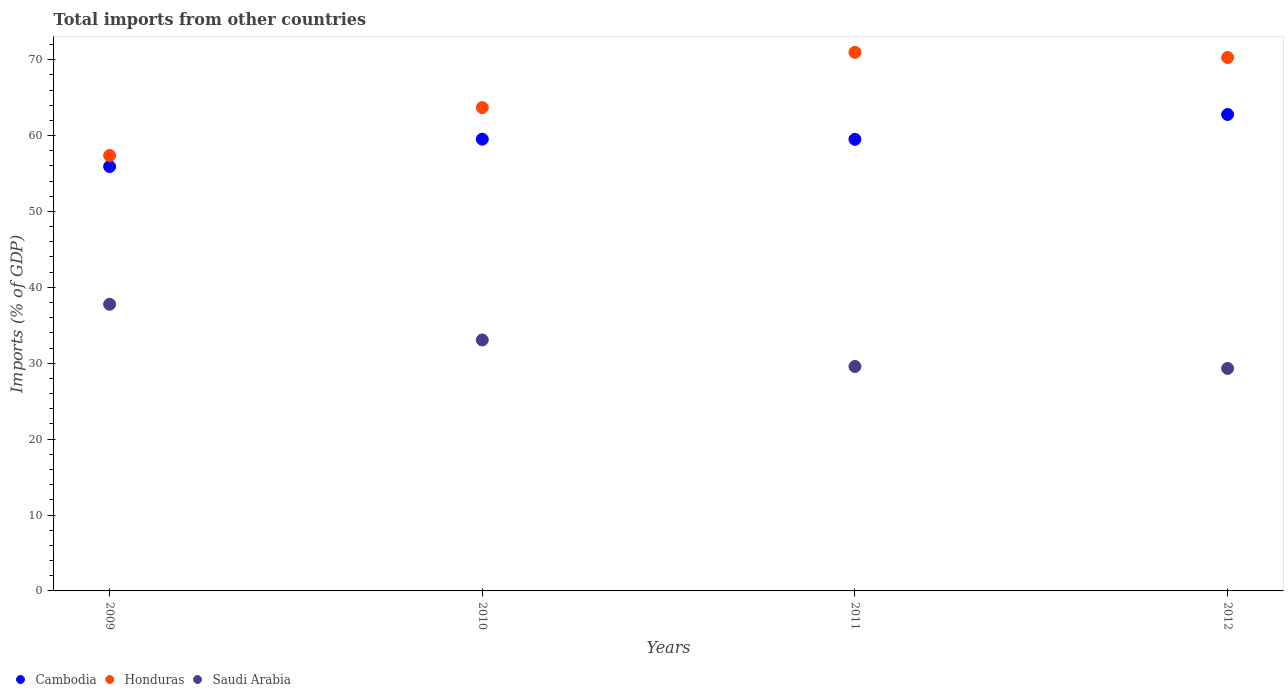How many different coloured dotlines are there?
Provide a succinct answer. 3. What is the total imports in Saudi Arabia in 2010?
Make the answer very short. 33.07. Across all years, what is the maximum total imports in Cambodia?
Your answer should be compact. 62.78. Across all years, what is the minimum total imports in Honduras?
Provide a succinct answer. 57.37. In which year was the total imports in Cambodia maximum?
Make the answer very short. 2012. What is the total total imports in Saudi Arabia in the graph?
Provide a short and direct response. 129.73. What is the difference between the total imports in Cambodia in 2010 and that in 2012?
Your answer should be very brief. -3.26. What is the difference between the total imports in Cambodia in 2011 and the total imports in Saudi Arabia in 2010?
Provide a short and direct response. 26.43. What is the average total imports in Cambodia per year?
Ensure brevity in your answer.  59.43. In the year 2012, what is the difference between the total imports in Cambodia and total imports in Saudi Arabia?
Your answer should be very brief. 33.46. What is the ratio of the total imports in Honduras in 2009 to that in 2012?
Ensure brevity in your answer.  0.82. What is the difference between the highest and the second highest total imports in Cambodia?
Give a very brief answer. 3.26. What is the difference between the highest and the lowest total imports in Honduras?
Ensure brevity in your answer.  13.58. Does the total imports in Honduras monotonically increase over the years?
Your response must be concise. No. Is the total imports in Honduras strictly greater than the total imports in Cambodia over the years?
Ensure brevity in your answer.  Yes. How many years are there in the graph?
Provide a short and direct response. 4. What is the difference between two consecutive major ticks on the Y-axis?
Your answer should be very brief. 10. Are the values on the major ticks of Y-axis written in scientific E-notation?
Your response must be concise. No. Where does the legend appear in the graph?
Make the answer very short. Bottom left. How many legend labels are there?
Provide a short and direct response. 3. What is the title of the graph?
Provide a short and direct response. Total imports from other countries. Does "Sri Lanka" appear as one of the legend labels in the graph?
Provide a short and direct response. No. What is the label or title of the X-axis?
Ensure brevity in your answer.  Years. What is the label or title of the Y-axis?
Your response must be concise. Imports (% of GDP). What is the Imports (% of GDP) of Cambodia in 2009?
Your answer should be very brief. 55.92. What is the Imports (% of GDP) of Honduras in 2009?
Make the answer very short. 57.37. What is the Imports (% of GDP) in Saudi Arabia in 2009?
Make the answer very short. 37.77. What is the Imports (% of GDP) in Cambodia in 2010?
Offer a terse response. 59.52. What is the Imports (% of GDP) of Honduras in 2010?
Offer a very short reply. 63.68. What is the Imports (% of GDP) of Saudi Arabia in 2010?
Provide a succinct answer. 33.07. What is the Imports (% of GDP) of Cambodia in 2011?
Make the answer very short. 59.5. What is the Imports (% of GDP) in Honduras in 2011?
Offer a very short reply. 70.96. What is the Imports (% of GDP) in Saudi Arabia in 2011?
Provide a succinct answer. 29.57. What is the Imports (% of GDP) of Cambodia in 2012?
Keep it short and to the point. 62.78. What is the Imports (% of GDP) in Honduras in 2012?
Offer a very short reply. 70.29. What is the Imports (% of GDP) in Saudi Arabia in 2012?
Your answer should be very brief. 29.32. Across all years, what is the maximum Imports (% of GDP) in Cambodia?
Offer a terse response. 62.78. Across all years, what is the maximum Imports (% of GDP) in Honduras?
Your answer should be very brief. 70.96. Across all years, what is the maximum Imports (% of GDP) of Saudi Arabia?
Offer a terse response. 37.77. Across all years, what is the minimum Imports (% of GDP) of Cambodia?
Your answer should be very brief. 55.92. Across all years, what is the minimum Imports (% of GDP) in Honduras?
Offer a very short reply. 57.37. Across all years, what is the minimum Imports (% of GDP) in Saudi Arabia?
Your answer should be compact. 29.32. What is the total Imports (% of GDP) of Cambodia in the graph?
Keep it short and to the point. 237.72. What is the total Imports (% of GDP) of Honduras in the graph?
Offer a very short reply. 262.3. What is the total Imports (% of GDP) in Saudi Arabia in the graph?
Offer a very short reply. 129.73. What is the difference between the Imports (% of GDP) in Cambodia in 2009 and that in 2010?
Offer a very short reply. -3.6. What is the difference between the Imports (% of GDP) of Honduras in 2009 and that in 2010?
Offer a terse response. -6.31. What is the difference between the Imports (% of GDP) of Saudi Arabia in 2009 and that in 2010?
Make the answer very short. 4.7. What is the difference between the Imports (% of GDP) of Cambodia in 2009 and that in 2011?
Your response must be concise. -3.58. What is the difference between the Imports (% of GDP) of Honduras in 2009 and that in 2011?
Ensure brevity in your answer.  -13.58. What is the difference between the Imports (% of GDP) in Saudi Arabia in 2009 and that in 2011?
Offer a very short reply. 8.2. What is the difference between the Imports (% of GDP) in Cambodia in 2009 and that in 2012?
Your answer should be compact. -6.86. What is the difference between the Imports (% of GDP) in Honduras in 2009 and that in 2012?
Provide a succinct answer. -12.91. What is the difference between the Imports (% of GDP) of Saudi Arabia in 2009 and that in 2012?
Ensure brevity in your answer.  8.45. What is the difference between the Imports (% of GDP) of Cambodia in 2010 and that in 2011?
Offer a terse response. 0.02. What is the difference between the Imports (% of GDP) in Honduras in 2010 and that in 2011?
Your answer should be compact. -7.28. What is the difference between the Imports (% of GDP) of Saudi Arabia in 2010 and that in 2011?
Make the answer very short. 3.5. What is the difference between the Imports (% of GDP) of Cambodia in 2010 and that in 2012?
Your answer should be very brief. -3.26. What is the difference between the Imports (% of GDP) in Honduras in 2010 and that in 2012?
Ensure brevity in your answer.  -6.6. What is the difference between the Imports (% of GDP) of Saudi Arabia in 2010 and that in 2012?
Your answer should be very brief. 3.75. What is the difference between the Imports (% of GDP) of Cambodia in 2011 and that in 2012?
Keep it short and to the point. -3.28. What is the difference between the Imports (% of GDP) of Honduras in 2011 and that in 2012?
Your answer should be compact. 0.67. What is the difference between the Imports (% of GDP) of Saudi Arabia in 2011 and that in 2012?
Provide a short and direct response. 0.25. What is the difference between the Imports (% of GDP) in Cambodia in 2009 and the Imports (% of GDP) in Honduras in 2010?
Give a very brief answer. -7.77. What is the difference between the Imports (% of GDP) in Cambodia in 2009 and the Imports (% of GDP) in Saudi Arabia in 2010?
Your answer should be very brief. 22.85. What is the difference between the Imports (% of GDP) in Honduras in 2009 and the Imports (% of GDP) in Saudi Arabia in 2010?
Keep it short and to the point. 24.31. What is the difference between the Imports (% of GDP) in Cambodia in 2009 and the Imports (% of GDP) in Honduras in 2011?
Your answer should be compact. -15.04. What is the difference between the Imports (% of GDP) of Cambodia in 2009 and the Imports (% of GDP) of Saudi Arabia in 2011?
Give a very brief answer. 26.35. What is the difference between the Imports (% of GDP) in Honduras in 2009 and the Imports (% of GDP) in Saudi Arabia in 2011?
Your answer should be very brief. 27.8. What is the difference between the Imports (% of GDP) in Cambodia in 2009 and the Imports (% of GDP) in Honduras in 2012?
Provide a short and direct response. -14.37. What is the difference between the Imports (% of GDP) of Cambodia in 2009 and the Imports (% of GDP) of Saudi Arabia in 2012?
Provide a succinct answer. 26.6. What is the difference between the Imports (% of GDP) in Honduras in 2009 and the Imports (% of GDP) in Saudi Arabia in 2012?
Provide a succinct answer. 28.05. What is the difference between the Imports (% of GDP) of Cambodia in 2010 and the Imports (% of GDP) of Honduras in 2011?
Your answer should be very brief. -11.44. What is the difference between the Imports (% of GDP) of Cambodia in 2010 and the Imports (% of GDP) of Saudi Arabia in 2011?
Ensure brevity in your answer.  29.95. What is the difference between the Imports (% of GDP) in Honduras in 2010 and the Imports (% of GDP) in Saudi Arabia in 2011?
Ensure brevity in your answer.  34.11. What is the difference between the Imports (% of GDP) in Cambodia in 2010 and the Imports (% of GDP) in Honduras in 2012?
Your response must be concise. -10.76. What is the difference between the Imports (% of GDP) in Cambodia in 2010 and the Imports (% of GDP) in Saudi Arabia in 2012?
Your response must be concise. 30.2. What is the difference between the Imports (% of GDP) of Honduras in 2010 and the Imports (% of GDP) of Saudi Arabia in 2012?
Make the answer very short. 34.36. What is the difference between the Imports (% of GDP) of Cambodia in 2011 and the Imports (% of GDP) of Honduras in 2012?
Give a very brief answer. -10.78. What is the difference between the Imports (% of GDP) of Cambodia in 2011 and the Imports (% of GDP) of Saudi Arabia in 2012?
Provide a succinct answer. 30.18. What is the difference between the Imports (% of GDP) in Honduras in 2011 and the Imports (% of GDP) in Saudi Arabia in 2012?
Offer a terse response. 41.64. What is the average Imports (% of GDP) in Cambodia per year?
Make the answer very short. 59.43. What is the average Imports (% of GDP) in Honduras per year?
Offer a terse response. 65.58. What is the average Imports (% of GDP) of Saudi Arabia per year?
Offer a very short reply. 32.43. In the year 2009, what is the difference between the Imports (% of GDP) of Cambodia and Imports (% of GDP) of Honduras?
Give a very brief answer. -1.46. In the year 2009, what is the difference between the Imports (% of GDP) of Cambodia and Imports (% of GDP) of Saudi Arabia?
Provide a succinct answer. 18.15. In the year 2009, what is the difference between the Imports (% of GDP) of Honduras and Imports (% of GDP) of Saudi Arabia?
Give a very brief answer. 19.61. In the year 2010, what is the difference between the Imports (% of GDP) of Cambodia and Imports (% of GDP) of Honduras?
Provide a succinct answer. -4.16. In the year 2010, what is the difference between the Imports (% of GDP) in Cambodia and Imports (% of GDP) in Saudi Arabia?
Your answer should be very brief. 26.45. In the year 2010, what is the difference between the Imports (% of GDP) of Honduras and Imports (% of GDP) of Saudi Arabia?
Provide a succinct answer. 30.62. In the year 2011, what is the difference between the Imports (% of GDP) in Cambodia and Imports (% of GDP) in Honduras?
Make the answer very short. -11.46. In the year 2011, what is the difference between the Imports (% of GDP) of Cambodia and Imports (% of GDP) of Saudi Arabia?
Your response must be concise. 29.93. In the year 2011, what is the difference between the Imports (% of GDP) in Honduras and Imports (% of GDP) in Saudi Arabia?
Offer a terse response. 41.39. In the year 2012, what is the difference between the Imports (% of GDP) of Cambodia and Imports (% of GDP) of Honduras?
Provide a succinct answer. -7.51. In the year 2012, what is the difference between the Imports (% of GDP) in Cambodia and Imports (% of GDP) in Saudi Arabia?
Provide a succinct answer. 33.46. In the year 2012, what is the difference between the Imports (% of GDP) of Honduras and Imports (% of GDP) of Saudi Arabia?
Your response must be concise. 40.96. What is the ratio of the Imports (% of GDP) in Cambodia in 2009 to that in 2010?
Provide a succinct answer. 0.94. What is the ratio of the Imports (% of GDP) in Honduras in 2009 to that in 2010?
Give a very brief answer. 0.9. What is the ratio of the Imports (% of GDP) in Saudi Arabia in 2009 to that in 2010?
Provide a succinct answer. 1.14. What is the ratio of the Imports (% of GDP) of Cambodia in 2009 to that in 2011?
Keep it short and to the point. 0.94. What is the ratio of the Imports (% of GDP) in Honduras in 2009 to that in 2011?
Your response must be concise. 0.81. What is the ratio of the Imports (% of GDP) in Saudi Arabia in 2009 to that in 2011?
Your answer should be compact. 1.28. What is the ratio of the Imports (% of GDP) of Cambodia in 2009 to that in 2012?
Ensure brevity in your answer.  0.89. What is the ratio of the Imports (% of GDP) of Honduras in 2009 to that in 2012?
Keep it short and to the point. 0.82. What is the ratio of the Imports (% of GDP) in Saudi Arabia in 2009 to that in 2012?
Offer a terse response. 1.29. What is the ratio of the Imports (% of GDP) in Cambodia in 2010 to that in 2011?
Offer a terse response. 1. What is the ratio of the Imports (% of GDP) in Honduras in 2010 to that in 2011?
Keep it short and to the point. 0.9. What is the ratio of the Imports (% of GDP) of Saudi Arabia in 2010 to that in 2011?
Ensure brevity in your answer.  1.12. What is the ratio of the Imports (% of GDP) in Cambodia in 2010 to that in 2012?
Your answer should be compact. 0.95. What is the ratio of the Imports (% of GDP) of Honduras in 2010 to that in 2012?
Ensure brevity in your answer.  0.91. What is the ratio of the Imports (% of GDP) of Saudi Arabia in 2010 to that in 2012?
Provide a succinct answer. 1.13. What is the ratio of the Imports (% of GDP) in Cambodia in 2011 to that in 2012?
Provide a short and direct response. 0.95. What is the ratio of the Imports (% of GDP) of Honduras in 2011 to that in 2012?
Ensure brevity in your answer.  1.01. What is the ratio of the Imports (% of GDP) in Saudi Arabia in 2011 to that in 2012?
Your answer should be compact. 1.01. What is the difference between the highest and the second highest Imports (% of GDP) in Cambodia?
Make the answer very short. 3.26. What is the difference between the highest and the second highest Imports (% of GDP) in Honduras?
Offer a terse response. 0.67. What is the difference between the highest and the second highest Imports (% of GDP) in Saudi Arabia?
Provide a short and direct response. 4.7. What is the difference between the highest and the lowest Imports (% of GDP) in Cambodia?
Offer a terse response. 6.86. What is the difference between the highest and the lowest Imports (% of GDP) in Honduras?
Your answer should be compact. 13.58. What is the difference between the highest and the lowest Imports (% of GDP) in Saudi Arabia?
Make the answer very short. 8.45. 